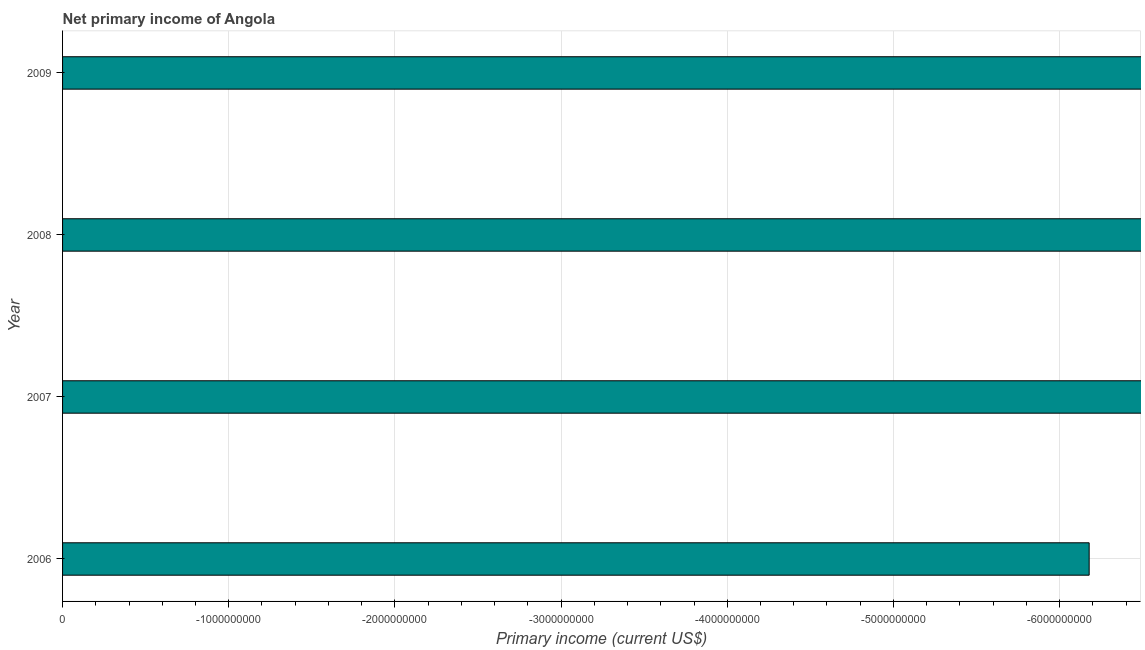Does the graph contain grids?
Offer a very short reply. Yes. What is the title of the graph?
Your answer should be very brief. Net primary income of Angola. What is the label or title of the X-axis?
Ensure brevity in your answer.  Primary income (current US$). What is the label or title of the Y-axis?
Make the answer very short. Year. What is the average amount of primary income per year?
Provide a short and direct response. 0. What is the median amount of primary income?
Keep it short and to the point. 0. How many bars are there?
Ensure brevity in your answer.  0. Are all the bars in the graph horizontal?
Offer a very short reply. Yes. How many years are there in the graph?
Make the answer very short. 4. What is the difference between two consecutive major ticks on the X-axis?
Offer a terse response. 1.00e+09. What is the Primary income (current US$) in 2008?
Offer a terse response. 0. What is the Primary income (current US$) in 2009?
Ensure brevity in your answer.  0. 